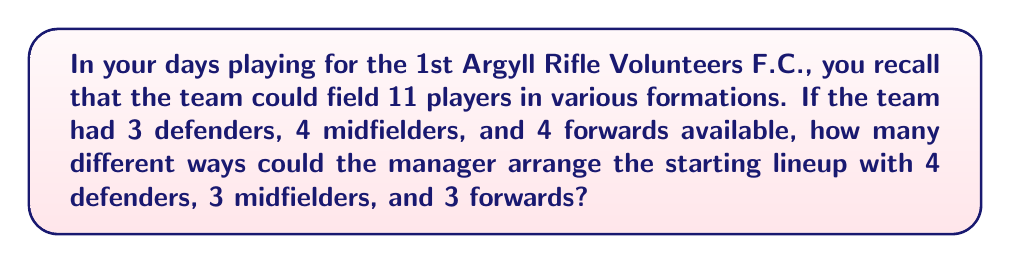Can you answer this question? Let's approach this step-by-step:

1) We need to choose:
   - 4 out of 3 defenders
   - 3 out of 4 midfielders
   - 3 out of 4 forwards

2) For the defenders:
   We need to choose 4 from 3, which is impossible. There's only one way to do this: use all 3 defenders.
   $${3 \choose 3} = 1$$

3) For the midfielders:
   We need to choose 3 from 4. This can be calculated as:
   $${4 \choose 3} = \frac{4!}{3!(4-3)!} = \frac{4!}{3!1!} = 4$$

4) For the forwards:
   We need to choose 3 from 4. This is the same as the midfielders:
   $${4 \choose 3} = 4$$

5) By the multiplication principle, the total number of ways to arrange the lineup is:
   $$1 \times 4 \times 4 = 16$$

Therefore, there are 16 different ways the manager could arrange the starting lineup.
Answer: 16 